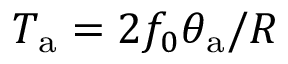Convert formula to latex. <formula><loc_0><loc_0><loc_500><loc_500>T _ { a } = 2 f _ { 0 } \theta _ { a } / R</formula> 